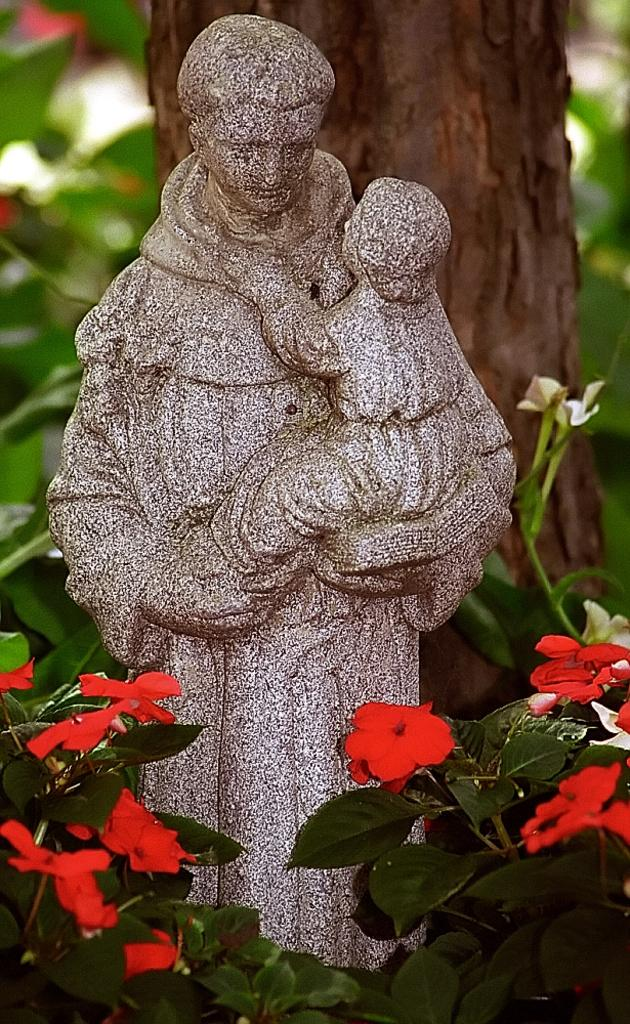What is the main subject in the middle of the image? There is a statue in the middle of the image. What can be seen at the bottom of the image? There are flowers and leaves at the bottom of the image. What is visible in the background of the image? There is a tree and leaves visible in the background of the image. What type of sock is hanging from the tree in the image? There is no sock present in the image; it only features a statue, flowers and leaves at the bottom, and a tree with leaves in the background. 